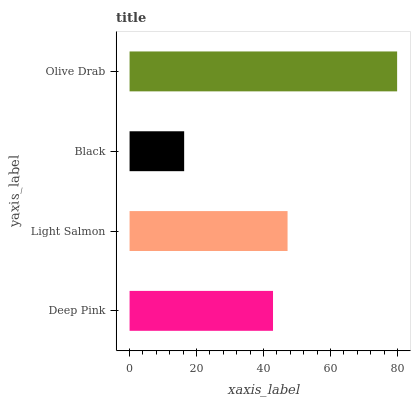Is Black the minimum?
Answer yes or no. Yes. Is Olive Drab the maximum?
Answer yes or no. Yes. Is Light Salmon the minimum?
Answer yes or no. No. Is Light Salmon the maximum?
Answer yes or no. No. Is Light Salmon greater than Deep Pink?
Answer yes or no. Yes. Is Deep Pink less than Light Salmon?
Answer yes or no. Yes. Is Deep Pink greater than Light Salmon?
Answer yes or no. No. Is Light Salmon less than Deep Pink?
Answer yes or no. No. Is Light Salmon the high median?
Answer yes or no. Yes. Is Deep Pink the low median?
Answer yes or no. Yes. Is Deep Pink the high median?
Answer yes or no. No. Is Olive Drab the low median?
Answer yes or no. No. 